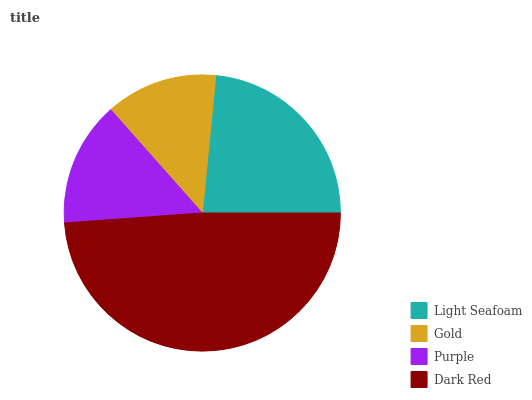Is Gold the minimum?
Answer yes or no. Yes. Is Dark Red the maximum?
Answer yes or no. Yes. Is Purple the minimum?
Answer yes or no. No. Is Purple the maximum?
Answer yes or no. No. Is Purple greater than Gold?
Answer yes or no. Yes. Is Gold less than Purple?
Answer yes or no. Yes. Is Gold greater than Purple?
Answer yes or no. No. Is Purple less than Gold?
Answer yes or no. No. Is Light Seafoam the high median?
Answer yes or no. Yes. Is Purple the low median?
Answer yes or no. Yes. Is Purple the high median?
Answer yes or no. No. Is Dark Red the low median?
Answer yes or no. No. 